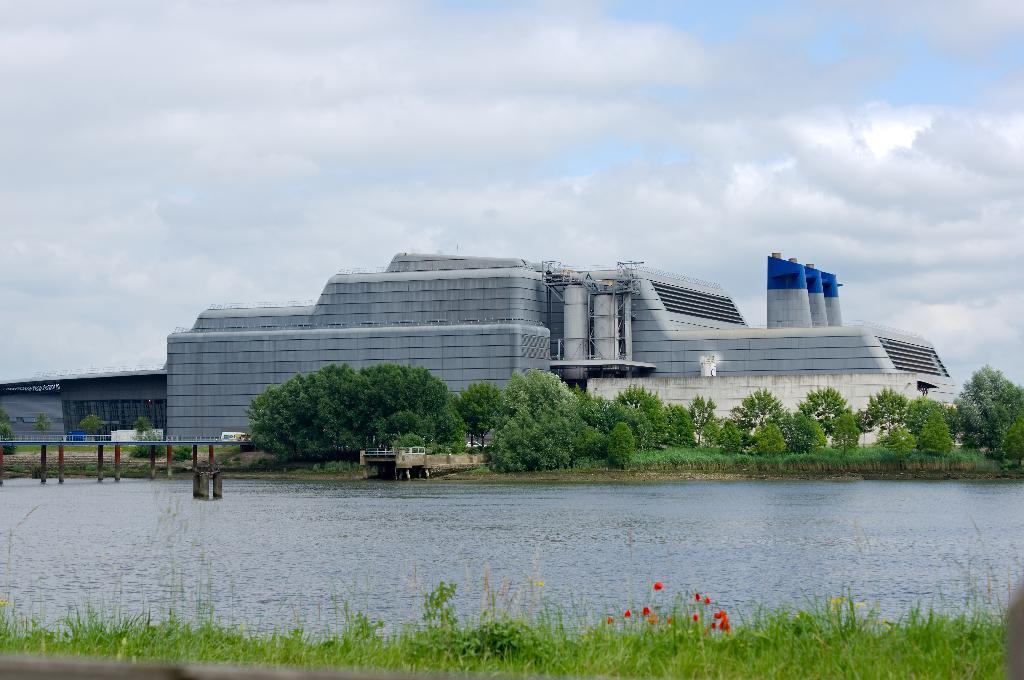Can you describe this image briefly? At the bottom of this image I can see the grass and some flowers and there is a sea. On the left side, I can see a bridge. On the other side of this sea there are some trees and buildings. On the top of the image I can see the sky and clouds. 